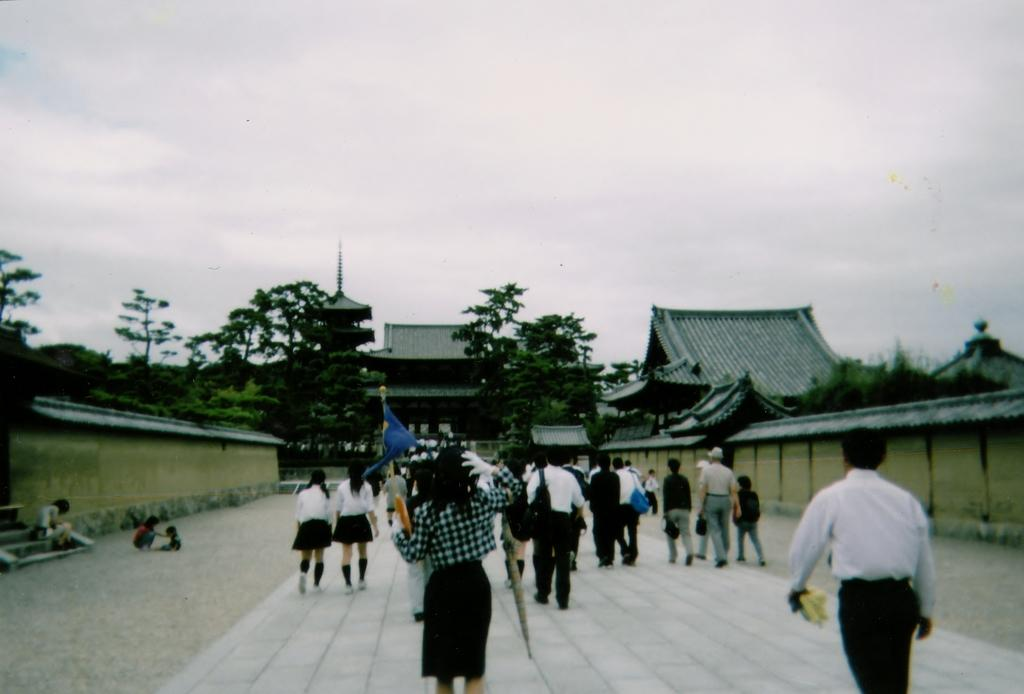What are the people in the image doing? The people in the image are walking on a path. What can be seen around the path in the image? There are many rooms and architectures around the path. What is visible in the background of the image? There are a lot of trees visible in the background of the image. What type of tooth is being used to cut the trees in the image? There is no tooth present in the image, and trees are not being cut. 